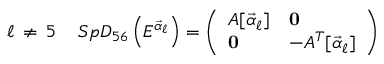<formula> <loc_0><loc_0><loc_500><loc_500>\ell \, \neq \, 5 \quad \, S p D _ { 5 6 } \left ( E ^ { { \vec { \alpha } } _ { \ell } } \right ) = \left ( \begin{array} { l l } { { A [ { { \vec { \alpha } } _ { \ell } } ] } } & { 0 } \\ { 0 } & { { - A ^ { T } [ { { \vec { \alpha } } _ { \ell } } ] } } \end{array} \right )</formula> 